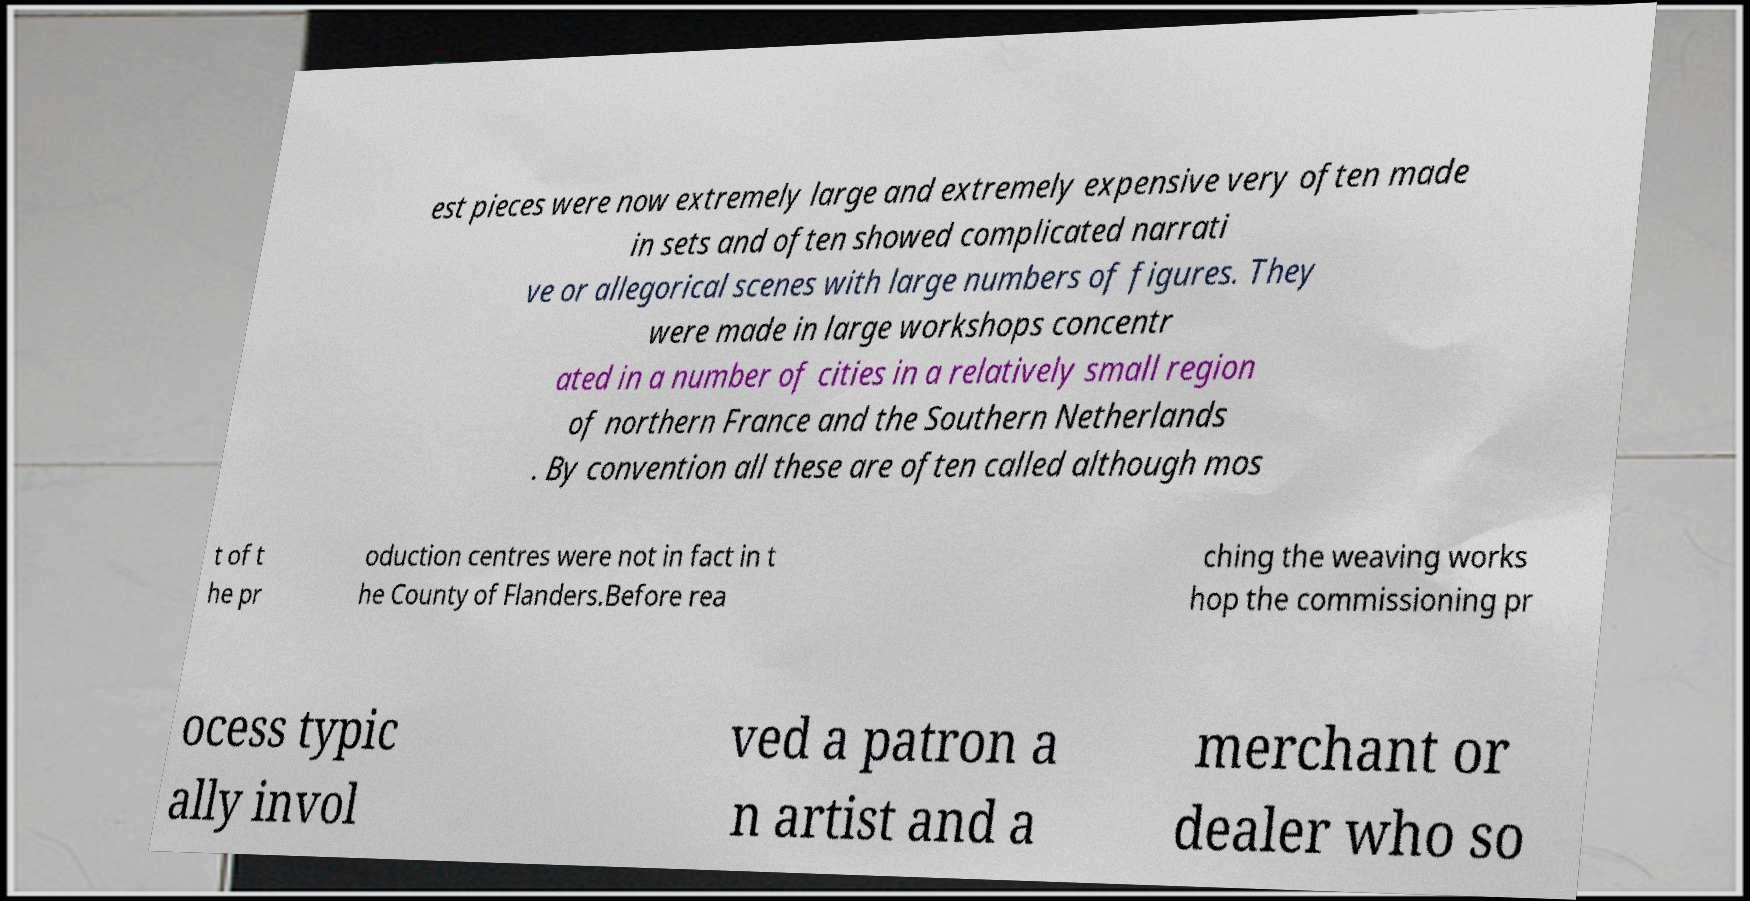What messages or text are displayed in this image? I need them in a readable, typed format. est pieces were now extremely large and extremely expensive very often made in sets and often showed complicated narrati ve or allegorical scenes with large numbers of figures. They were made in large workshops concentr ated in a number of cities in a relatively small region of northern France and the Southern Netherlands . By convention all these are often called although mos t of t he pr oduction centres were not in fact in t he County of Flanders.Before rea ching the weaving works hop the commissioning pr ocess typic ally invol ved a patron a n artist and a merchant or dealer who so 